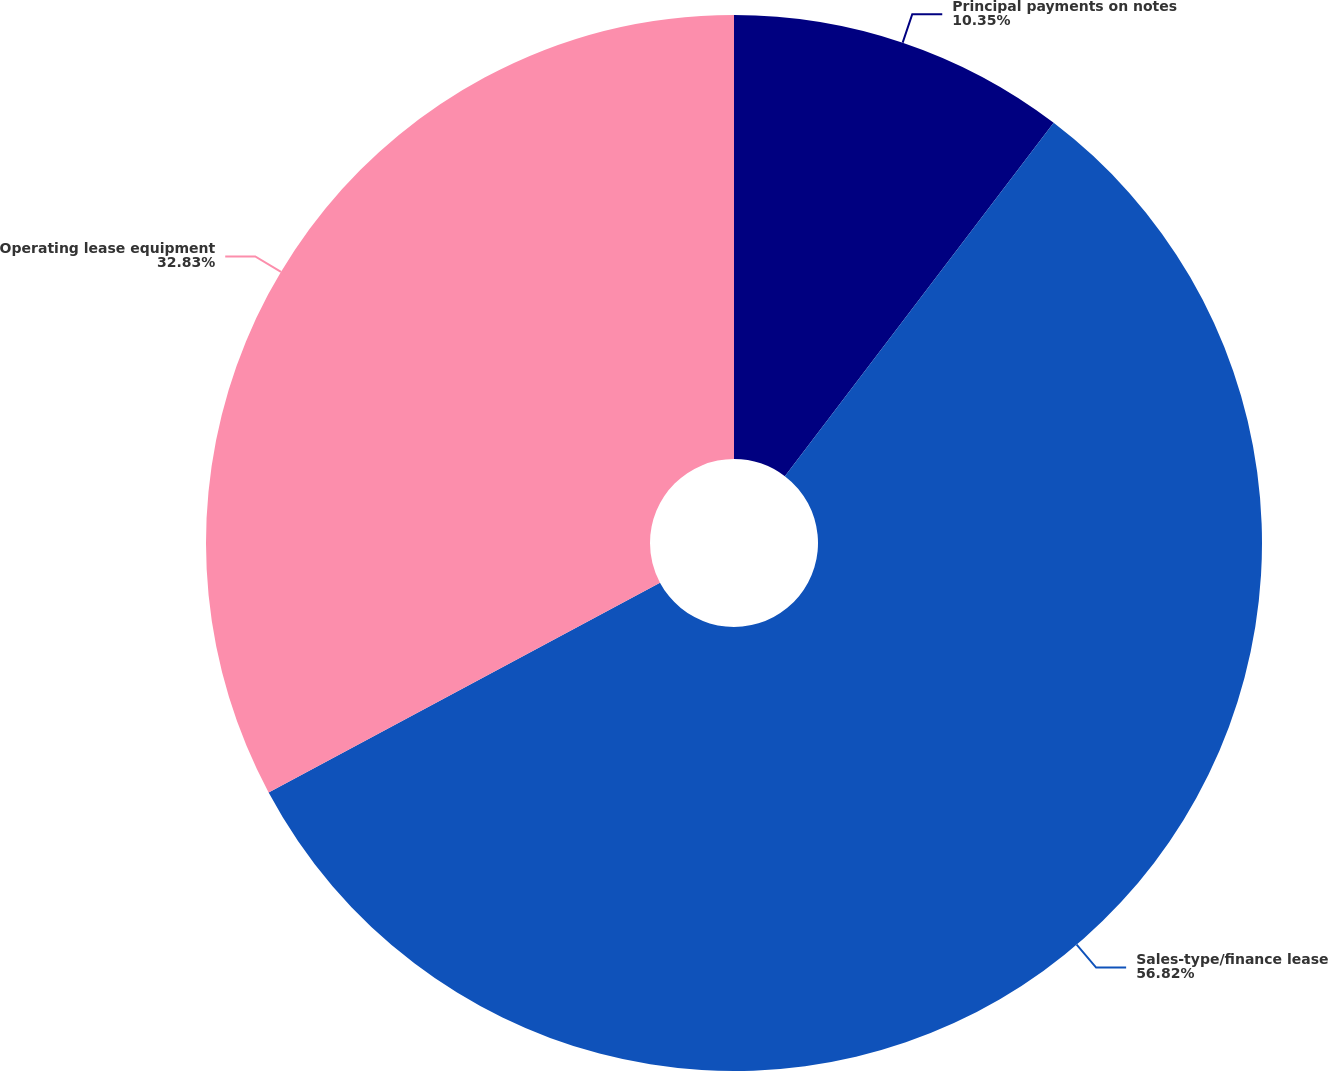Convert chart to OTSL. <chart><loc_0><loc_0><loc_500><loc_500><pie_chart><fcel>Principal payments on notes<fcel>Sales-type/finance lease<fcel>Operating lease equipment<nl><fcel>10.35%<fcel>56.82%<fcel>32.83%<nl></chart> 